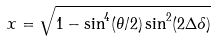<formula> <loc_0><loc_0><loc_500><loc_500>x = \sqrt { 1 - \sin ^ { 4 } ( \theta / 2 ) \sin ^ { 2 } ( 2 \Delta \delta ) }</formula> 